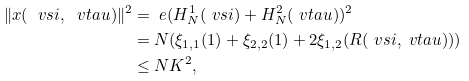Convert formula to latex. <formula><loc_0><loc_0><loc_500><loc_500>\| x ( \ v s i , \ v t a u ) \| ^ { 2 } & = \ e ( H _ { N } ^ { 1 } ( \ v s i ) + H _ { N } ^ { 2 } ( \ v t a u ) ) ^ { 2 } \\ & = N ( \xi _ { 1 , 1 } ( 1 ) + \xi _ { 2 , 2 } ( 1 ) + 2 \xi _ { 1 , 2 } ( R ( \ v s i , \ v t a u ) ) ) \\ & \leq N K ^ { 2 } ,</formula> 